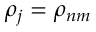Convert formula to latex. <formula><loc_0><loc_0><loc_500><loc_500>{ \rho } _ { j } = { \rho } _ { n m }</formula> 